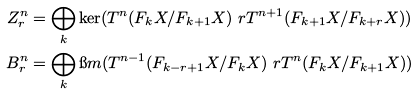Convert formula to latex. <formula><loc_0><loc_0><loc_500><loc_500>Z ^ { n } _ { r } & = \bigoplus _ { k } \ker ( T ^ { n } ( F _ { k } X / F _ { k + 1 } X ) \ r T ^ { n + 1 } ( F _ { k + 1 } X / F _ { k + r } X ) ) \\ B ^ { n } _ { r } & = \bigoplus _ { k } \i m ( T ^ { n - 1 } ( F _ { k - r + 1 } X / F _ { k } X ) \ r T ^ { n } ( F _ { k } X / F _ { k + 1 } X ) )</formula> 